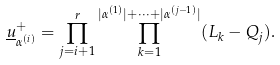Convert formula to latex. <formula><loc_0><loc_0><loc_500><loc_500>\underline { u } ^ { + } _ { \alpha ^ { ( i ) } } = \prod _ { j = i + 1 } ^ { r } \prod _ { k = 1 } ^ { | \alpha ^ { ( 1 ) } | + \cdots + | \alpha ^ { ( j - 1 ) } | } ( L _ { k } - Q _ { j } ) .</formula> 